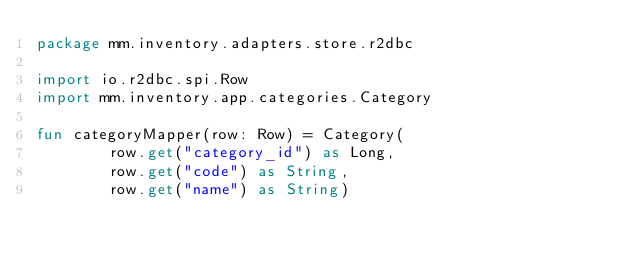<code> <loc_0><loc_0><loc_500><loc_500><_Kotlin_>package mm.inventory.adapters.store.r2dbc

import io.r2dbc.spi.Row
import mm.inventory.app.categories.Category

fun categoryMapper(row: Row) = Category(
        row.get("category_id") as Long,
        row.get("code") as String,
        row.get("name") as String)</code> 